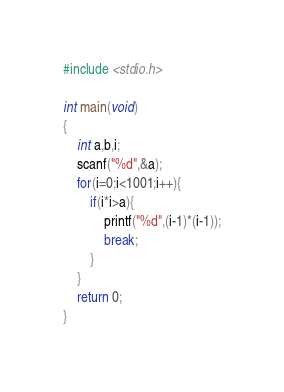Convert code to text. <code><loc_0><loc_0><loc_500><loc_500><_C_>#include <stdio.h>

int main(void)
{
	int a,b,i;
	scanf("%d",&a);
	for(i=0;i<1001;i++){
		if(i*i>a){
			printf("%d",(i-1)*(i-1));
			break;
		}
	}
	return 0;
}</code> 